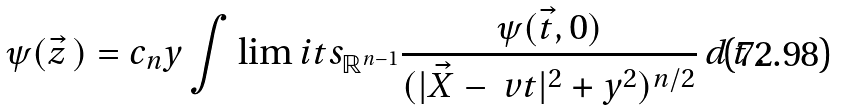<formula> <loc_0><loc_0><loc_500><loc_500>\psi ( \vec { z } \, ) = c _ { n } y \int \lim i t s _ { \mathbb { R } ^ { n - 1 } } \frac { \psi ( \vec { t } , 0 ) } { ( | \vec { X } - \ v t | ^ { 2 } + y ^ { 2 } ) ^ { n / 2 } } \, d \, t \ .</formula> 